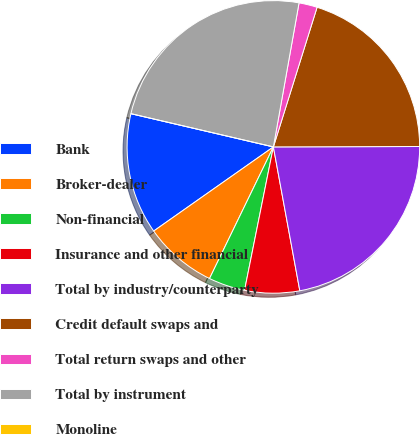Convert chart to OTSL. <chart><loc_0><loc_0><loc_500><loc_500><pie_chart><fcel>Bank<fcel>Broker-dealer<fcel>Non-financial<fcel>Insurance and other financial<fcel>Total by industry/counterparty<fcel>Credit default swaps and<fcel>Total return swaps and other<fcel>Total by instrument<fcel>Monoline<nl><fcel>13.4%<fcel>8.06%<fcel>4.03%<fcel>6.05%<fcel>22.15%<fcel>20.13%<fcel>2.02%<fcel>24.16%<fcel>0.0%<nl></chart> 